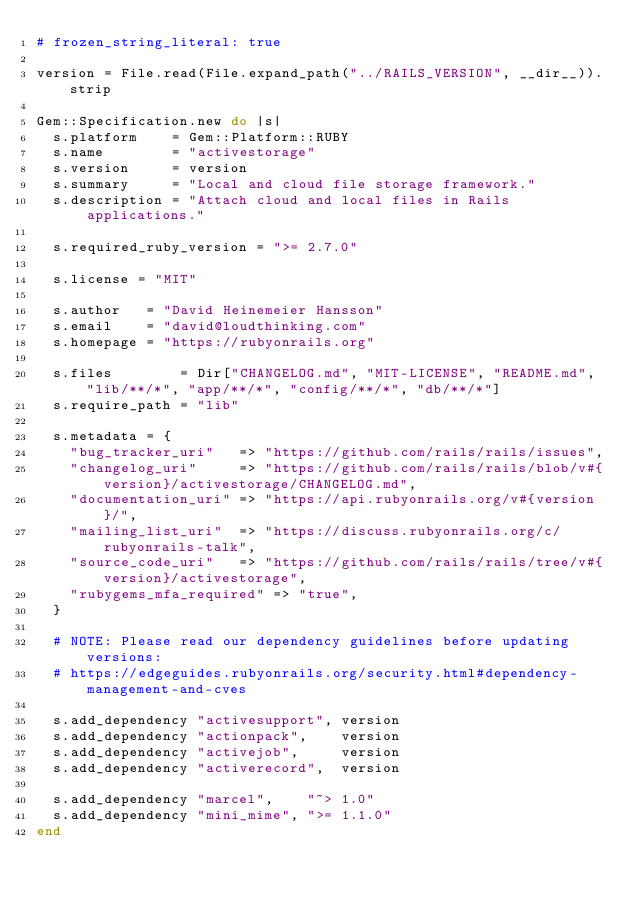Convert code to text. <code><loc_0><loc_0><loc_500><loc_500><_Ruby_># frozen_string_literal: true

version = File.read(File.expand_path("../RAILS_VERSION", __dir__)).strip

Gem::Specification.new do |s|
  s.platform    = Gem::Platform::RUBY
  s.name        = "activestorage"
  s.version     = version
  s.summary     = "Local and cloud file storage framework."
  s.description = "Attach cloud and local files in Rails applications."

  s.required_ruby_version = ">= 2.7.0"

  s.license = "MIT"

  s.author   = "David Heinemeier Hansson"
  s.email    = "david@loudthinking.com"
  s.homepage = "https://rubyonrails.org"

  s.files        = Dir["CHANGELOG.md", "MIT-LICENSE", "README.md", "lib/**/*", "app/**/*", "config/**/*", "db/**/*"]
  s.require_path = "lib"

  s.metadata = {
    "bug_tracker_uri"   => "https://github.com/rails/rails/issues",
    "changelog_uri"     => "https://github.com/rails/rails/blob/v#{version}/activestorage/CHANGELOG.md",
    "documentation_uri" => "https://api.rubyonrails.org/v#{version}/",
    "mailing_list_uri"  => "https://discuss.rubyonrails.org/c/rubyonrails-talk",
    "source_code_uri"   => "https://github.com/rails/rails/tree/v#{version}/activestorage",
    "rubygems_mfa_required" => "true",
  }

  # NOTE: Please read our dependency guidelines before updating versions:
  # https://edgeguides.rubyonrails.org/security.html#dependency-management-and-cves

  s.add_dependency "activesupport", version
  s.add_dependency "actionpack",    version
  s.add_dependency "activejob",     version
  s.add_dependency "activerecord",  version

  s.add_dependency "marcel",    "~> 1.0"
  s.add_dependency "mini_mime", ">= 1.1.0"
end
</code> 